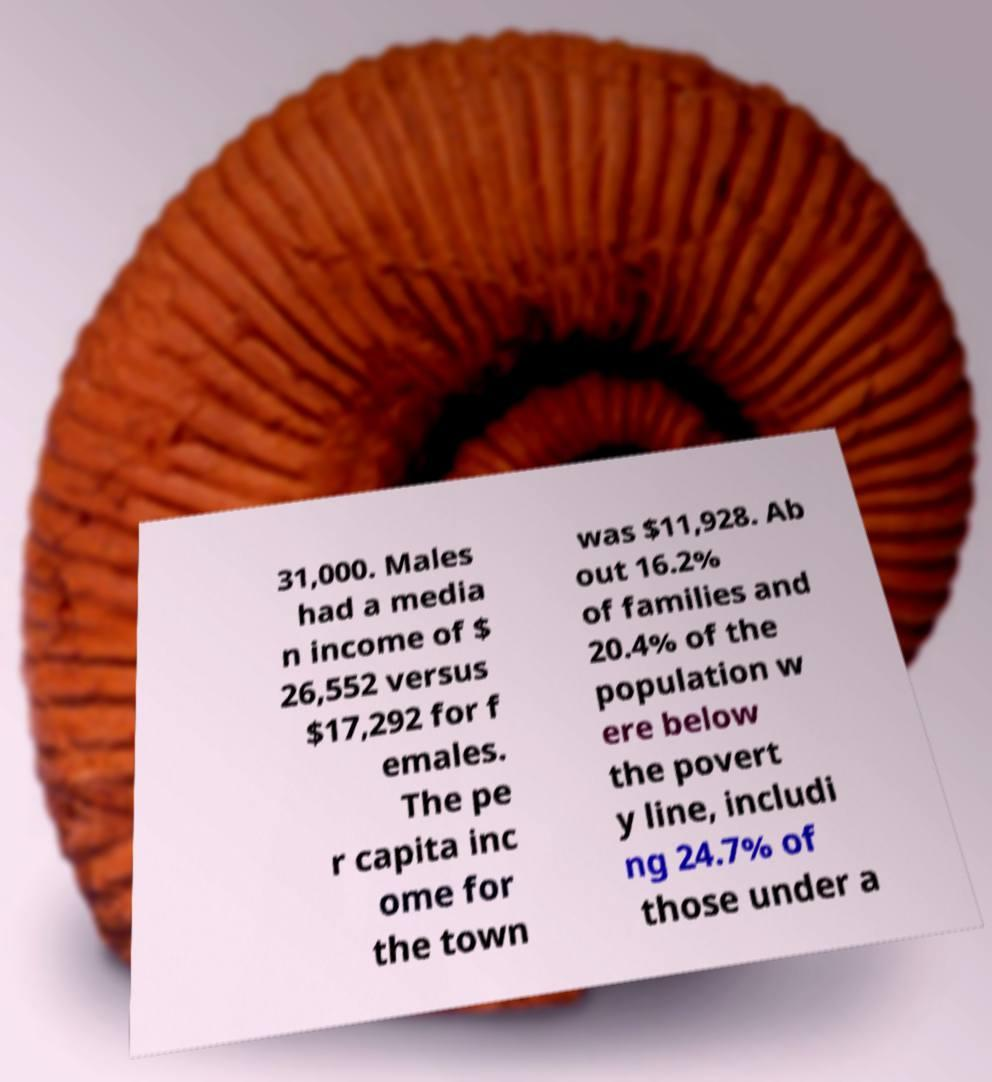Can you read and provide the text displayed in the image?This photo seems to have some interesting text. Can you extract and type it out for me? 31,000. Males had a media n income of $ 26,552 versus $17,292 for f emales. The pe r capita inc ome for the town was $11,928. Ab out 16.2% of families and 20.4% of the population w ere below the povert y line, includi ng 24.7% of those under a 